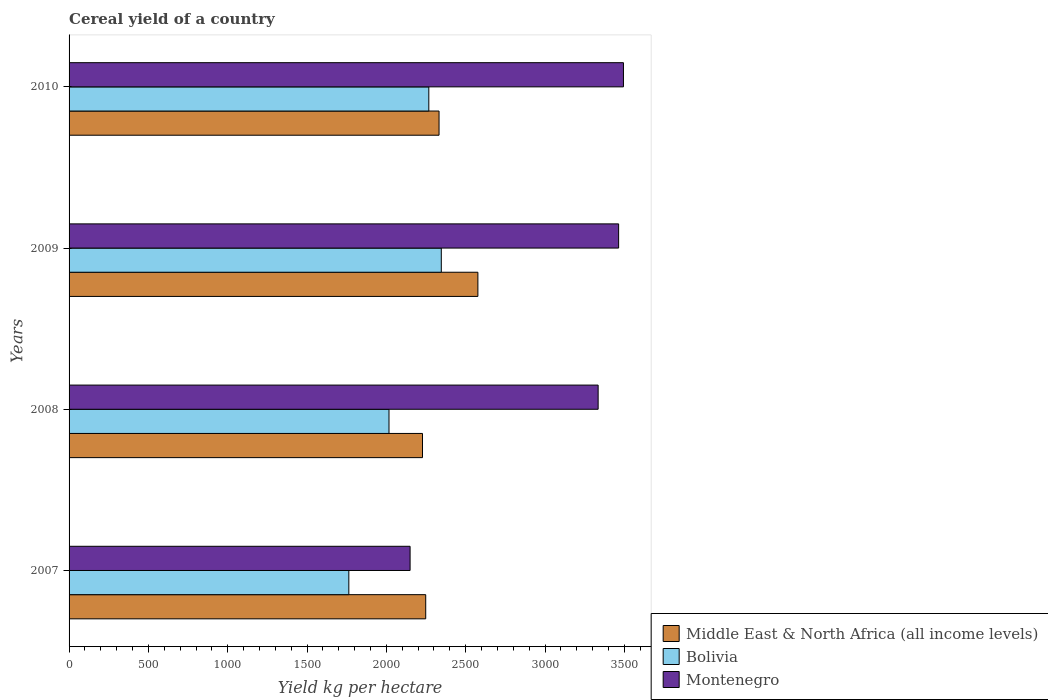How many bars are there on the 3rd tick from the top?
Offer a very short reply. 3. How many bars are there on the 1st tick from the bottom?
Offer a terse response. 3. What is the label of the 4th group of bars from the top?
Provide a succinct answer. 2007. What is the total cereal yield in Montenegro in 2009?
Your answer should be compact. 3463.75. Across all years, what is the maximum total cereal yield in Middle East & North Africa (all income levels)?
Ensure brevity in your answer.  2576.68. Across all years, what is the minimum total cereal yield in Bolivia?
Your response must be concise. 1763.27. In which year was the total cereal yield in Bolivia maximum?
Your response must be concise. 2009. In which year was the total cereal yield in Montenegro minimum?
Your answer should be very brief. 2007. What is the total total cereal yield in Bolivia in the graph?
Offer a very short reply. 8393.09. What is the difference between the total cereal yield in Middle East & North Africa (all income levels) in 2007 and that in 2009?
Keep it short and to the point. -328.79. What is the difference between the total cereal yield in Middle East & North Africa (all income levels) in 2009 and the total cereal yield in Montenegro in 2008?
Your answer should be very brief. -757.91. What is the average total cereal yield in Montenegro per year?
Give a very brief answer. 3110.45. In the year 2007, what is the difference between the total cereal yield in Middle East & North Africa (all income levels) and total cereal yield in Bolivia?
Give a very brief answer. 484.63. What is the ratio of the total cereal yield in Middle East & North Africa (all income levels) in 2009 to that in 2010?
Offer a very short reply. 1.11. Is the total cereal yield in Middle East & North Africa (all income levels) in 2008 less than that in 2009?
Ensure brevity in your answer.  Yes. Is the difference between the total cereal yield in Middle East & North Africa (all income levels) in 2008 and 2009 greater than the difference between the total cereal yield in Bolivia in 2008 and 2009?
Give a very brief answer. No. What is the difference between the highest and the second highest total cereal yield in Bolivia?
Make the answer very short. 78.7. What is the difference between the highest and the lowest total cereal yield in Bolivia?
Keep it short and to the point. 582.77. In how many years, is the total cereal yield in Middle East & North Africa (all income levels) greater than the average total cereal yield in Middle East & North Africa (all income levels) taken over all years?
Provide a succinct answer. 1. What does the 3rd bar from the top in 2010 represents?
Provide a short and direct response. Middle East & North Africa (all income levels). What does the 1st bar from the bottom in 2010 represents?
Your response must be concise. Middle East & North Africa (all income levels). How many bars are there?
Offer a very short reply. 12. Are all the bars in the graph horizontal?
Offer a terse response. Yes. How many years are there in the graph?
Your answer should be very brief. 4. Are the values on the major ticks of X-axis written in scientific E-notation?
Ensure brevity in your answer.  No. Does the graph contain grids?
Your response must be concise. No. How many legend labels are there?
Ensure brevity in your answer.  3. How are the legend labels stacked?
Offer a terse response. Vertical. What is the title of the graph?
Ensure brevity in your answer.  Cereal yield of a country. Does "Italy" appear as one of the legend labels in the graph?
Make the answer very short. No. What is the label or title of the X-axis?
Your answer should be very brief. Yield kg per hectare. What is the label or title of the Y-axis?
Your answer should be compact. Years. What is the Yield kg per hectare in Middle East & North Africa (all income levels) in 2007?
Offer a very short reply. 2247.9. What is the Yield kg per hectare of Bolivia in 2007?
Give a very brief answer. 1763.27. What is the Yield kg per hectare in Montenegro in 2007?
Your answer should be very brief. 2149.37. What is the Yield kg per hectare of Middle East & North Africa (all income levels) in 2008?
Offer a very short reply. 2227.54. What is the Yield kg per hectare in Bolivia in 2008?
Your answer should be compact. 2016.43. What is the Yield kg per hectare in Montenegro in 2008?
Ensure brevity in your answer.  3334.6. What is the Yield kg per hectare in Middle East & North Africa (all income levels) in 2009?
Make the answer very short. 2576.68. What is the Yield kg per hectare of Bolivia in 2009?
Keep it short and to the point. 2346.04. What is the Yield kg per hectare of Montenegro in 2009?
Offer a very short reply. 3463.75. What is the Yield kg per hectare of Middle East & North Africa (all income levels) in 2010?
Make the answer very short. 2331.83. What is the Yield kg per hectare in Bolivia in 2010?
Provide a succinct answer. 2267.35. What is the Yield kg per hectare in Montenegro in 2010?
Provide a short and direct response. 3494.09. Across all years, what is the maximum Yield kg per hectare in Middle East & North Africa (all income levels)?
Your response must be concise. 2576.68. Across all years, what is the maximum Yield kg per hectare of Bolivia?
Your answer should be very brief. 2346.04. Across all years, what is the maximum Yield kg per hectare of Montenegro?
Keep it short and to the point. 3494.09. Across all years, what is the minimum Yield kg per hectare in Middle East & North Africa (all income levels)?
Your answer should be compact. 2227.54. Across all years, what is the minimum Yield kg per hectare of Bolivia?
Provide a short and direct response. 1763.27. Across all years, what is the minimum Yield kg per hectare of Montenegro?
Your answer should be very brief. 2149.37. What is the total Yield kg per hectare in Middle East & North Africa (all income levels) in the graph?
Your answer should be very brief. 9383.95. What is the total Yield kg per hectare of Bolivia in the graph?
Give a very brief answer. 8393.09. What is the total Yield kg per hectare of Montenegro in the graph?
Provide a short and direct response. 1.24e+04. What is the difference between the Yield kg per hectare of Middle East & North Africa (all income levels) in 2007 and that in 2008?
Your answer should be compact. 20.36. What is the difference between the Yield kg per hectare of Bolivia in 2007 and that in 2008?
Offer a very short reply. -253.16. What is the difference between the Yield kg per hectare of Montenegro in 2007 and that in 2008?
Keep it short and to the point. -1185.23. What is the difference between the Yield kg per hectare of Middle East & North Africa (all income levels) in 2007 and that in 2009?
Your answer should be very brief. -328.79. What is the difference between the Yield kg per hectare of Bolivia in 2007 and that in 2009?
Offer a terse response. -582.77. What is the difference between the Yield kg per hectare in Montenegro in 2007 and that in 2009?
Offer a terse response. -1314.38. What is the difference between the Yield kg per hectare of Middle East & North Africa (all income levels) in 2007 and that in 2010?
Give a very brief answer. -83.93. What is the difference between the Yield kg per hectare in Bolivia in 2007 and that in 2010?
Your answer should be compact. -504.08. What is the difference between the Yield kg per hectare in Montenegro in 2007 and that in 2010?
Make the answer very short. -1344.72. What is the difference between the Yield kg per hectare of Middle East & North Africa (all income levels) in 2008 and that in 2009?
Ensure brevity in your answer.  -349.14. What is the difference between the Yield kg per hectare of Bolivia in 2008 and that in 2009?
Make the answer very short. -329.61. What is the difference between the Yield kg per hectare of Montenegro in 2008 and that in 2009?
Make the answer very short. -129.15. What is the difference between the Yield kg per hectare in Middle East & North Africa (all income levels) in 2008 and that in 2010?
Give a very brief answer. -104.29. What is the difference between the Yield kg per hectare in Bolivia in 2008 and that in 2010?
Your answer should be compact. -250.91. What is the difference between the Yield kg per hectare of Montenegro in 2008 and that in 2010?
Make the answer very short. -159.49. What is the difference between the Yield kg per hectare of Middle East & North Africa (all income levels) in 2009 and that in 2010?
Ensure brevity in your answer.  244.85. What is the difference between the Yield kg per hectare of Bolivia in 2009 and that in 2010?
Give a very brief answer. 78.7. What is the difference between the Yield kg per hectare in Montenegro in 2009 and that in 2010?
Ensure brevity in your answer.  -30.34. What is the difference between the Yield kg per hectare of Middle East & North Africa (all income levels) in 2007 and the Yield kg per hectare of Bolivia in 2008?
Ensure brevity in your answer.  231.47. What is the difference between the Yield kg per hectare in Middle East & North Africa (all income levels) in 2007 and the Yield kg per hectare in Montenegro in 2008?
Your answer should be very brief. -1086.7. What is the difference between the Yield kg per hectare of Bolivia in 2007 and the Yield kg per hectare of Montenegro in 2008?
Keep it short and to the point. -1571.33. What is the difference between the Yield kg per hectare in Middle East & North Africa (all income levels) in 2007 and the Yield kg per hectare in Bolivia in 2009?
Offer a very short reply. -98.15. What is the difference between the Yield kg per hectare in Middle East & North Africa (all income levels) in 2007 and the Yield kg per hectare in Montenegro in 2009?
Provide a succinct answer. -1215.85. What is the difference between the Yield kg per hectare of Bolivia in 2007 and the Yield kg per hectare of Montenegro in 2009?
Provide a succinct answer. -1700.48. What is the difference between the Yield kg per hectare of Middle East & North Africa (all income levels) in 2007 and the Yield kg per hectare of Bolivia in 2010?
Offer a terse response. -19.45. What is the difference between the Yield kg per hectare of Middle East & North Africa (all income levels) in 2007 and the Yield kg per hectare of Montenegro in 2010?
Your answer should be very brief. -1246.19. What is the difference between the Yield kg per hectare of Bolivia in 2007 and the Yield kg per hectare of Montenegro in 2010?
Give a very brief answer. -1730.82. What is the difference between the Yield kg per hectare of Middle East & North Africa (all income levels) in 2008 and the Yield kg per hectare of Bolivia in 2009?
Your response must be concise. -118.5. What is the difference between the Yield kg per hectare in Middle East & North Africa (all income levels) in 2008 and the Yield kg per hectare in Montenegro in 2009?
Give a very brief answer. -1236.21. What is the difference between the Yield kg per hectare in Bolivia in 2008 and the Yield kg per hectare in Montenegro in 2009?
Offer a very short reply. -1447.32. What is the difference between the Yield kg per hectare in Middle East & North Africa (all income levels) in 2008 and the Yield kg per hectare in Bolivia in 2010?
Give a very brief answer. -39.81. What is the difference between the Yield kg per hectare of Middle East & North Africa (all income levels) in 2008 and the Yield kg per hectare of Montenegro in 2010?
Ensure brevity in your answer.  -1266.55. What is the difference between the Yield kg per hectare in Bolivia in 2008 and the Yield kg per hectare in Montenegro in 2010?
Ensure brevity in your answer.  -1477.66. What is the difference between the Yield kg per hectare of Middle East & North Africa (all income levels) in 2009 and the Yield kg per hectare of Bolivia in 2010?
Provide a succinct answer. 309.34. What is the difference between the Yield kg per hectare of Middle East & North Africa (all income levels) in 2009 and the Yield kg per hectare of Montenegro in 2010?
Give a very brief answer. -917.41. What is the difference between the Yield kg per hectare of Bolivia in 2009 and the Yield kg per hectare of Montenegro in 2010?
Ensure brevity in your answer.  -1148.05. What is the average Yield kg per hectare of Middle East & North Africa (all income levels) per year?
Ensure brevity in your answer.  2345.99. What is the average Yield kg per hectare of Bolivia per year?
Offer a very short reply. 2098.27. What is the average Yield kg per hectare in Montenegro per year?
Provide a succinct answer. 3110.45. In the year 2007, what is the difference between the Yield kg per hectare in Middle East & North Africa (all income levels) and Yield kg per hectare in Bolivia?
Your response must be concise. 484.63. In the year 2007, what is the difference between the Yield kg per hectare of Middle East & North Africa (all income levels) and Yield kg per hectare of Montenegro?
Provide a succinct answer. 98.53. In the year 2007, what is the difference between the Yield kg per hectare in Bolivia and Yield kg per hectare in Montenegro?
Ensure brevity in your answer.  -386.1. In the year 2008, what is the difference between the Yield kg per hectare in Middle East & North Africa (all income levels) and Yield kg per hectare in Bolivia?
Your answer should be very brief. 211.11. In the year 2008, what is the difference between the Yield kg per hectare of Middle East & North Africa (all income levels) and Yield kg per hectare of Montenegro?
Offer a very short reply. -1107.06. In the year 2008, what is the difference between the Yield kg per hectare of Bolivia and Yield kg per hectare of Montenegro?
Your response must be concise. -1318.17. In the year 2009, what is the difference between the Yield kg per hectare in Middle East & North Africa (all income levels) and Yield kg per hectare in Bolivia?
Your response must be concise. 230.64. In the year 2009, what is the difference between the Yield kg per hectare in Middle East & North Africa (all income levels) and Yield kg per hectare in Montenegro?
Give a very brief answer. -887.06. In the year 2009, what is the difference between the Yield kg per hectare of Bolivia and Yield kg per hectare of Montenegro?
Keep it short and to the point. -1117.7. In the year 2010, what is the difference between the Yield kg per hectare of Middle East & North Africa (all income levels) and Yield kg per hectare of Bolivia?
Offer a terse response. 64.48. In the year 2010, what is the difference between the Yield kg per hectare in Middle East & North Africa (all income levels) and Yield kg per hectare in Montenegro?
Offer a very short reply. -1162.26. In the year 2010, what is the difference between the Yield kg per hectare of Bolivia and Yield kg per hectare of Montenegro?
Your answer should be very brief. -1226.74. What is the ratio of the Yield kg per hectare of Middle East & North Africa (all income levels) in 2007 to that in 2008?
Offer a very short reply. 1.01. What is the ratio of the Yield kg per hectare in Bolivia in 2007 to that in 2008?
Make the answer very short. 0.87. What is the ratio of the Yield kg per hectare in Montenegro in 2007 to that in 2008?
Offer a very short reply. 0.64. What is the ratio of the Yield kg per hectare in Middle East & North Africa (all income levels) in 2007 to that in 2009?
Offer a very short reply. 0.87. What is the ratio of the Yield kg per hectare of Bolivia in 2007 to that in 2009?
Ensure brevity in your answer.  0.75. What is the ratio of the Yield kg per hectare in Montenegro in 2007 to that in 2009?
Offer a terse response. 0.62. What is the ratio of the Yield kg per hectare in Bolivia in 2007 to that in 2010?
Offer a terse response. 0.78. What is the ratio of the Yield kg per hectare of Montenegro in 2007 to that in 2010?
Keep it short and to the point. 0.62. What is the ratio of the Yield kg per hectare in Middle East & North Africa (all income levels) in 2008 to that in 2009?
Provide a short and direct response. 0.86. What is the ratio of the Yield kg per hectare in Bolivia in 2008 to that in 2009?
Your response must be concise. 0.86. What is the ratio of the Yield kg per hectare of Montenegro in 2008 to that in 2009?
Offer a terse response. 0.96. What is the ratio of the Yield kg per hectare of Middle East & North Africa (all income levels) in 2008 to that in 2010?
Offer a very short reply. 0.96. What is the ratio of the Yield kg per hectare of Bolivia in 2008 to that in 2010?
Provide a succinct answer. 0.89. What is the ratio of the Yield kg per hectare of Montenegro in 2008 to that in 2010?
Offer a very short reply. 0.95. What is the ratio of the Yield kg per hectare of Middle East & North Africa (all income levels) in 2009 to that in 2010?
Offer a very short reply. 1.1. What is the ratio of the Yield kg per hectare in Bolivia in 2009 to that in 2010?
Provide a short and direct response. 1.03. What is the ratio of the Yield kg per hectare of Montenegro in 2009 to that in 2010?
Ensure brevity in your answer.  0.99. What is the difference between the highest and the second highest Yield kg per hectare of Middle East & North Africa (all income levels)?
Make the answer very short. 244.85. What is the difference between the highest and the second highest Yield kg per hectare in Bolivia?
Provide a succinct answer. 78.7. What is the difference between the highest and the second highest Yield kg per hectare of Montenegro?
Give a very brief answer. 30.34. What is the difference between the highest and the lowest Yield kg per hectare of Middle East & North Africa (all income levels)?
Make the answer very short. 349.14. What is the difference between the highest and the lowest Yield kg per hectare of Bolivia?
Offer a terse response. 582.77. What is the difference between the highest and the lowest Yield kg per hectare of Montenegro?
Your response must be concise. 1344.72. 